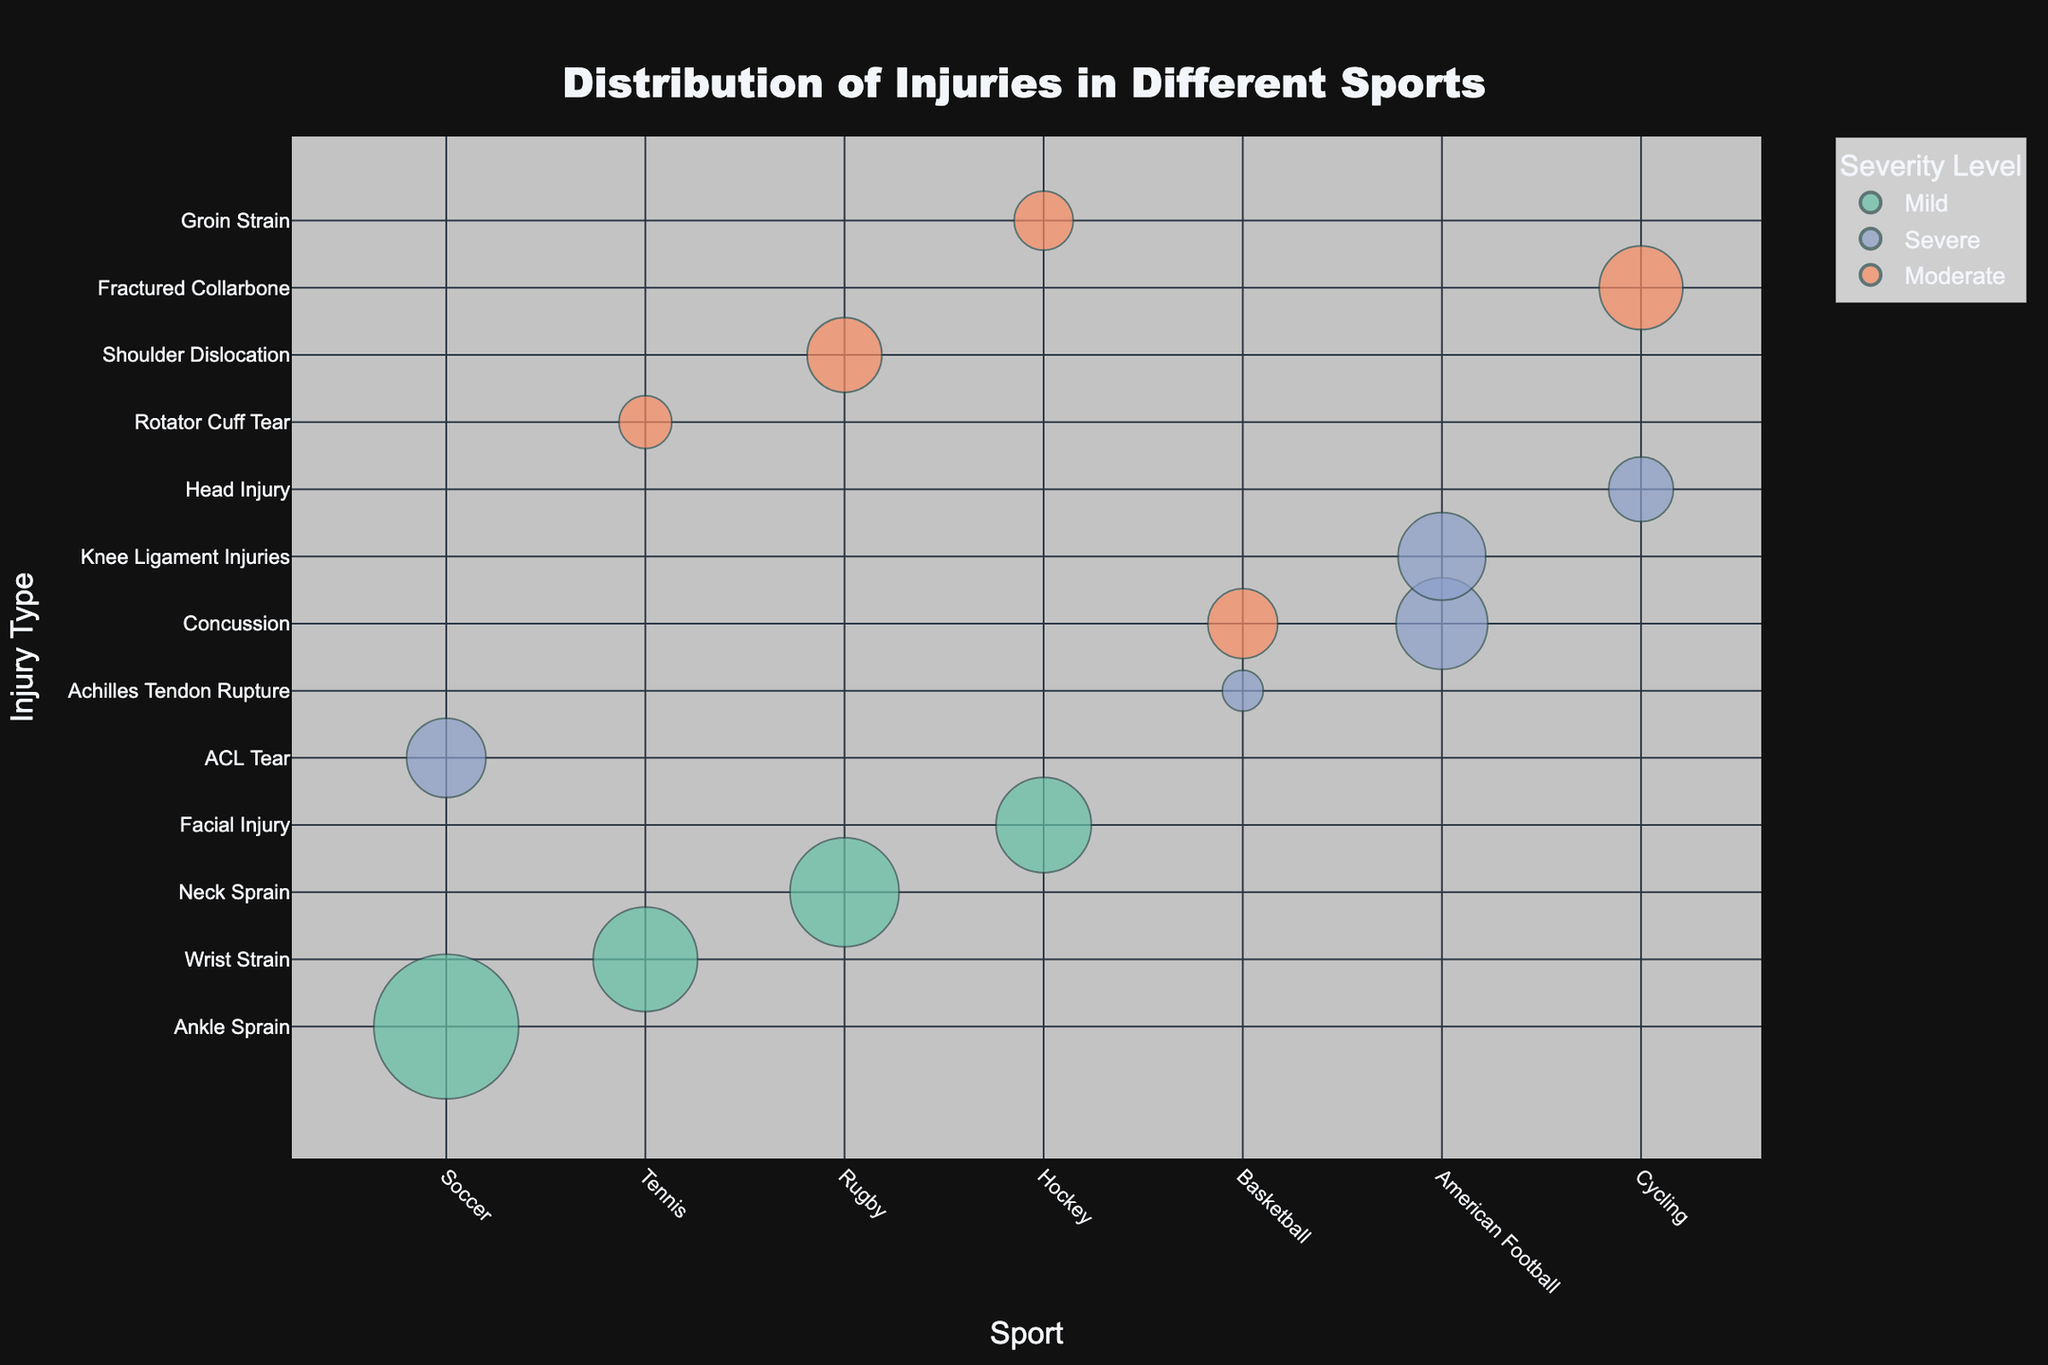Which sport has the highest number of incidents for a severe injury? To determine this, look at the size of the bubbles in the severe injury category for each sport. The largest bubble will indicate the highest number of incidents.
Answer: American Football In Tennis, which type of injury occurs most frequently? In the figure, observe the size of the bubbles for each injury type within Tennis. The largest bubble represents the most frequent injury.
Answer: Wrist Strain How many types of severe injuries are there in Soccer? Identify the bubbles in the figure associated with Soccer. Then, count the number of bubbles that are colored to indicate severe injuries.
Answer: 1 Compare the number of moderate injuries in Rugby and Basketball. Which one has more? Locate the bubbles for Rugby and Basketball with the moderate injury color. Compare the sizes of these bubbles to determine which sport has more.
Answer: Rugby What is the total number of mild injuries in Soccer and Rugby? Add the number of incidents for the mild injuries in Soccer and Rugby. Soccer has 150 mild injuries and Rugby has 85 mild injuries. So, the total is 150 + 85.
Answer: 235 What is the most common injury type in Cycling? Look for the largest bubble for Cycling. The largest bubble will indicate the most common injury type.
Answer: Fractured Collarbone Which sport has the largest number of incidents for concussions? Identify the bubbles associated with concussions across different sports. The largest bubble will indicate the sport with the highest number of incidents.
Answer: American Football Are there more mild injuries or severe injuries in American Football? Compare the sizes of the bubbles indicating mild and severe injuries in American Football. Mild injuries will have bubbles colored in mild colors, and severe injuries in severe colors. There is no bubble indicating mild injuries, while there are two representing severe injuries.
Answer: Severe injuries Which sport has the most diverse types of injuries? Count the different injury types for each sport by looking at the vertical spread of the bubbles within each sport’s category. The sport with the most different injury types has the highest diversity.
Answer: Soccer For which injury type and sport is there a moderate severity incident count of 35? Identify the moderate severity color and check the incident count in the hover data for each bubble. Match these details with the sport and injury type.
Answer: Concussion in Basketball 